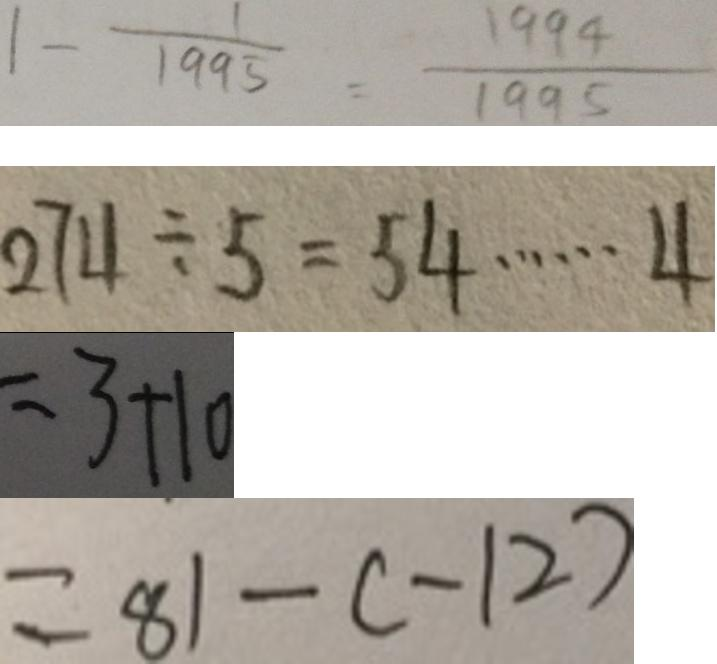Convert formula to latex. <formula><loc_0><loc_0><loc_500><loc_500>1 - \frac { 1 } { 1 9 9 5 } = \frac { 1 9 9 4 } { 1 9 9 5 } 
 2 7 4 \div 5 = 5 4 \cdots 4 
 = 3 + 1 0 
 = 8 1 - ( - 1 2 )</formula> 